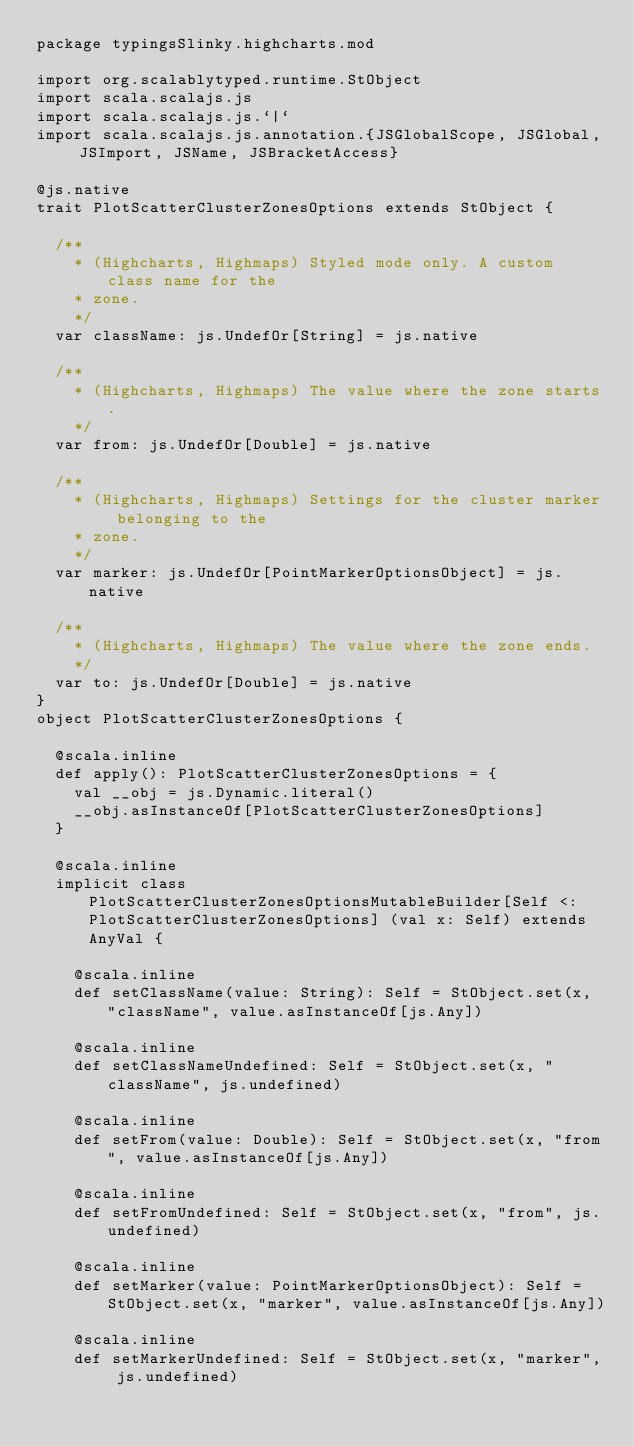Convert code to text. <code><loc_0><loc_0><loc_500><loc_500><_Scala_>package typingsSlinky.highcharts.mod

import org.scalablytyped.runtime.StObject
import scala.scalajs.js
import scala.scalajs.js.`|`
import scala.scalajs.js.annotation.{JSGlobalScope, JSGlobal, JSImport, JSName, JSBracketAccess}

@js.native
trait PlotScatterClusterZonesOptions extends StObject {
  
  /**
    * (Highcharts, Highmaps) Styled mode only. A custom class name for the
    * zone.
    */
  var className: js.UndefOr[String] = js.native
  
  /**
    * (Highcharts, Highmaps) The value where the zone starts.
    */
  var from: js.UndefOr[Double] = js.native
  
  /**
    * (Highcharts, Highmaps) Settings for the cluster marker belonging to the
    * zone.
    */
  var marker: js.UndefOr[PointMarkerOptionsObject] = js.native
  
  /**
    * (Highcharts, Highmaps) The value where the zone ends.
    */
  var to: js.UndefOr[Double] = js.native
}
object PlotScatterClusterZonesOptions {
  
  @scala.inline
  def apply(): PlotScatterClusterZonesOptions = {
    val __obj = js.Dynamic.literal()
    __obj.asInstanceOf[PlotScatterClusterZonesOptions]
  }
  
  @scala.inline
  implicit class PlotScatterClusterZonesOptionsMutableBuilder[Self <: PlotScatterClusterZonesOptions] (val x: Self) extends AnyVal {
    
    @scala.inline
    def setClassName(value: String): Self = StObject.set(x, "className", value.asInstanceOf[js.Any])
    
    @scala.inline
    def setClassNameUndefined: Self = StObject.set(x, "className", js.undefined)
    
    @scala.inline
    def setFrom(value: Double): Self = StObject.set(x, "from", value.asInstanceOf[js.Any])
    
    @scala.inline
    def setFromUndefined: Self = StObject.set(x, "from", js.undefined)
    
    @scala.inline
    def setMarker(value: PointMarkerOptionsObject): Self = StObject.set(x, "marker", value.asInstanceOf[js.Any])
    
    @scala.inline
    def setMarkerUndefined: Self = StObject.set(x, "marker", js.undefined)
    </code> 